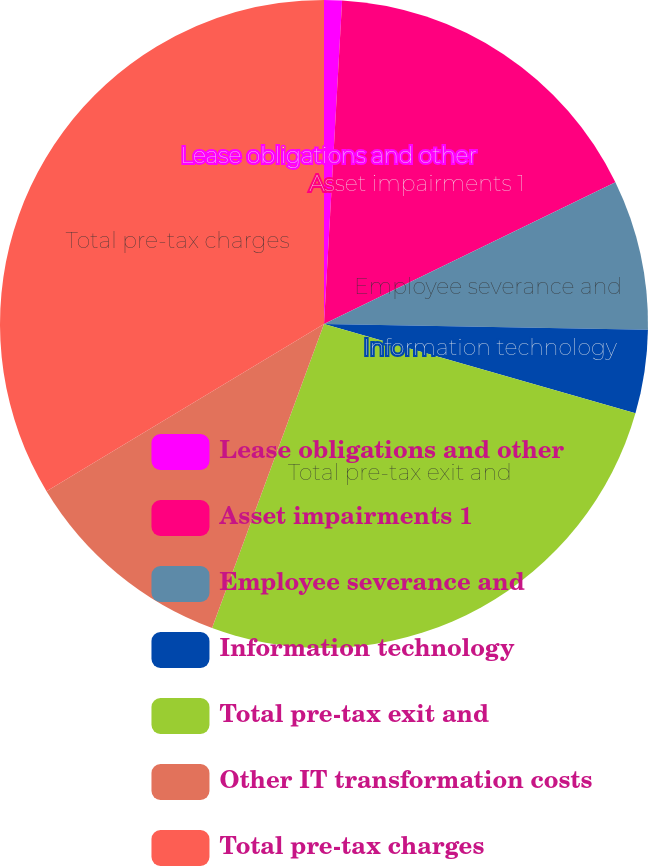Convert chart to OTSL. <chart><loc_0><loc_0><loc_500><loc_500><pie_chart><fcel>Lease obligations and other<fcel>Asset impairments 1<fcel>Employee severance and<fcel>Information technology<fcel>Total pre-tax exit and<fcel>Other IT transformation costs<fcel>Total pre-tax charges<nl><fcel>0.89%<fcel>16.91%<fcel>7.48%<fcel>4.17%<fcel>26.17%<fcel>10.75%<fcel>33.64%<nl></chart> 